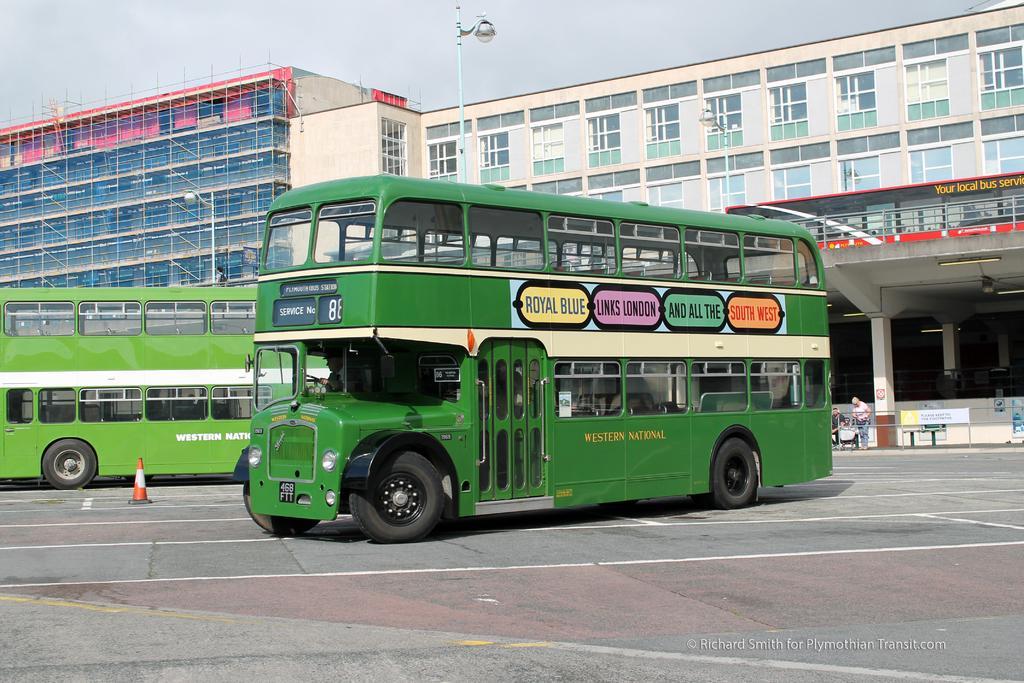Describe this image in one or two sentences. In this picture I can see Double Decker buses on the road, there is a cone bar barricade, there are few people, there are boards, there are buildings, and in the background there is the sky and there is a watermark on the image. 